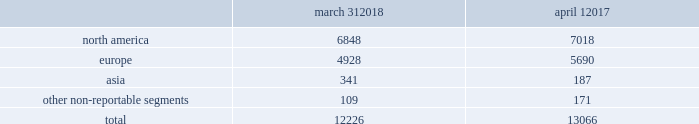Concession-based shop-within-shops .
In addition , we sell our products online through various third-party digital partner commerce sites .
In asia , our wholesale business is comprised primarily of sales to department stores , with related products distributed through shop-within-shops .
No operating segments were aggregated to form our reportable segments .
In addition to these reportable segments , we also have other non-reportable segments , representing approximately 7% ( 7 % ) of our fiscal 2018 net revenues , which primarily consist of ( i ) sales of club monaco branded products made through our retail businesses in the u.s. , canada , and europe , and our licensing alliances in europe and asia , ( ii ) sales of ralph lauren branded products made through our wholesale business in latin america , and ( iii ) royalty revenues earned through our global licensing alliances , excluding club monaco .
This segment structure is consistent with how we establish our overall business strategy , allocate resources , and assess performance of our company .
Approximately 45% ( 45 % ) of our fiscal 2018 net revenues were earned outside of the u.s .
See note 19 to the accompanying consolidated financial statements for a summary of net revenues and operating income by segment , as well as net revenues and long-lived assets by geographic location .
Our wholesale business our wholesale business sells our products globally to leading upscale and certain mid-tier department stores , specialty stores , and golf and pro shops .
We have continued to focus on elevating our brand by improving in-store product assortment and presentation , as well as full-price sell-throughs to consumers .
As of the end of fiscal 2018 , our wholesale products were sold through over 12000 doors worldwide , with the majority in specialty stores .
Our products are also increasingly being sold through the digital commerce sites of many of our wholesale customers .
The primary product offerings sold through our wholesale channels of distribution include apparel , accessories , and home furnishings .
Our luxury brands , including ralph lauren collection and ralph lauren purple label , are distributed worldwide through a limited number of premier fashion retailers .
In north america , our wholesale business is comprised primarily of sales to department stores , and to a lesser extent , specialty stores .
In europe , our wholesale business is comprised of a varying mix of sales to both department stores and specialty stores , depending on the country .
In asia , our wholesale business is comprised primarily of sales to department stores , with related products distributed through shop-within-shops .
We also distribute our wholesale products to certain licensed stores operated by our partners in latin america , asia , europe , and the middle east .
We sell the majority of our excess and out-of-season products through secondary distribution channels worldwide , including our retail factory stores .
Worldwide wholesale distribution channels the table presents by segment the number of wholesale doors in our primary channels of distribution as of march 31 , 2018 and april 1 , march 31 , april 1 .
We have three key wholesale customers that generate significant sales volume .
During fiscal 2018 , sales to our largest wholesale customer , macy's , inc .
( "macy's" ) , accounted for approximately 8% ( 8 % ) of our total net revenues .
Further , during fiscal 2018 , sales to our three largest wholesale customers , including macy's , accounted for approximately 19% ( 19 % ) of our total net revenues , as compared to approximately 21% ( 21 % ) during fiscal 2017 .
Substantially all sales to our three largest wholesale customers related to our north america segment .
Our products are sold primarily by our own sales forces .
Our wholesale business maintains its primary showrooms in new york city .
In addition , we maintain regional showrooms in bologna , geneva , london , madrid , munich , panama , paris , and stockholm. .
What percentage of wholesale distribution channels are due to europe as of march 31 , 2018? 
Computations: (4928 / 12226)
Answer: 0.40308. 